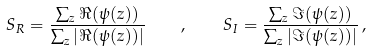Convert formula to latex. <formula><loc_0><loc_0><loc_500><loc_500>S _ { R } = \frac { \sum _ { z } \Re ( \psi ( z ) ) } { \sum _ { z } | \Re ( \psi ( z ) ) | } \quad , \quad S _ { I } = \frac { \sum _ { z } \Im ( \psi ( z ) ) } { \sum _ { z } | \Im ( \psi ( z ) ) | } \, ,</formula> 